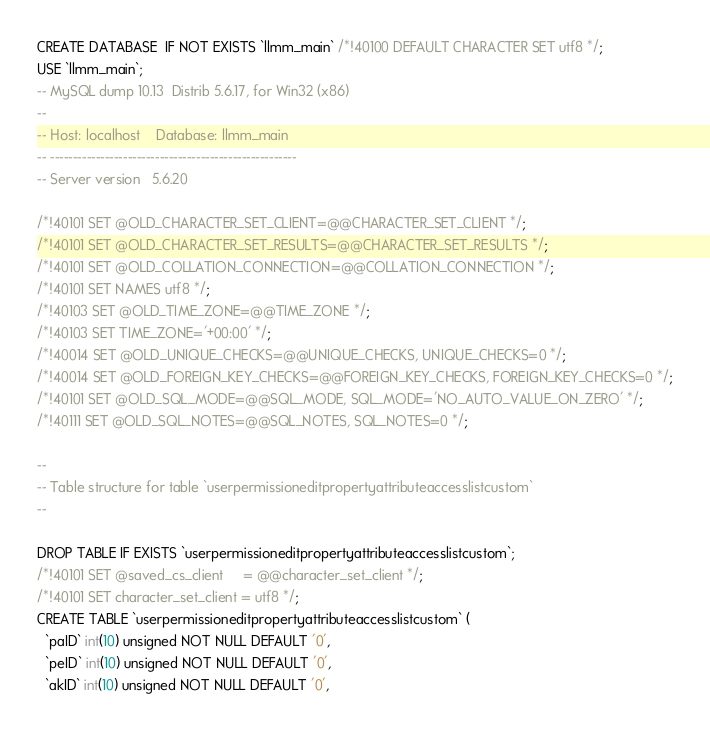<code> <loc_0><loc_0><loc_500><loc_500><_SQL_>CREATE DATABASE  IF NOT EXISTS `llmm_main` /*!40100 DEFAULT CHARACTER SET utf8 */;
USE `llmm_main`;
-- MySQL dump 10.13  Distrib 5.6.17, for Win32 (x86)
--
-- Host: localhost    Database: llmm_main
-- ------------------------------------------------------
-- Server version	5.6.20

/*!40101 SET @OLD_CHARACTER_SET_CLIENT=@@CHARACTER_SET_CLIENT */;
/*!40101 SET @OLD_CHARACTER_SET_RESULTS=@@CHARACTER_SET_RESULTS */;
/*!40101 SET @OLD_COLLATION_CONNECTION=@@COLLATION_CONNECTION */;
/*!40101 SET NAMES utf8 */;
/*!40103 SET @OLD_TIME_ZONE=@@TIME_ZONE */;
/*!40103 SET TIME_ZONE='+00:00' */;
/*!40014 SET @OLD_UNIQUE_CHECKS=@@UNIQUE_CHECKS, UNIQUE_CHECKS=0 */;
/*!40014 SET @OLD_FOREIGN_KEY_CHECKS=@@FOREIGN_KEY_CHECKS, FOREIGN_KEY_CHECKS=0 */;
/*!40101 SET @OLD_SQL_MODE=@@SQL_MODE, SQL_MODE='NO_AUTO_VALUE_ON_ZERO' */;
/*!40111 SET @OLD_SQL_NOTES=@@SQL_NOTES, SQL_NOTES=0 */;

--
-- Table structure for table `userpermissioneditpropertyattributeaccesslistcustom`
--

DROP TABLE IF EXISTS `userpermissioneditpropertyattributeaccesslistcustom`;
/*!40101 SET @saved_cs_client     = @@character_set_client */;
/*!40101 SET character_set_client = utf8 */;
CREATE TABLE `userpermissioneditpropertyattributeaccesslistcustom` (
  `paID` int(10) unsigned NOT NULL DEFAULT '0',
  `peID` int(10) unsigned NOT NULL DEFAULT '0',
  `akID` int(10) unsigned NOT NULL DEFAULT '0',</code> 